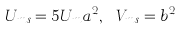<formula> <loc_0><loc_0><loc_500><loc_500>U _ { m s } = 5 U _ { m } a ^ { 2 } , \text { } V _ { m s } = b ^ { 2 }</formula> 